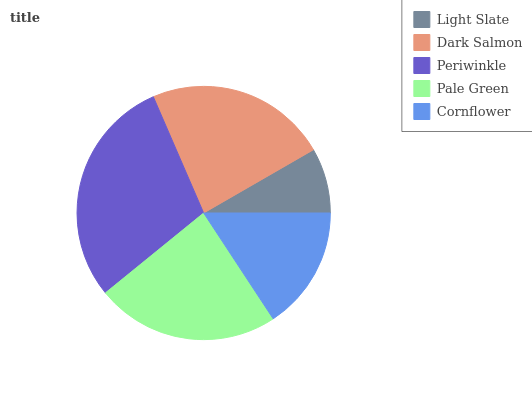Is Light Slate the minimum?
Answer yes or no. Yes. Is Periwinkle the maximum?
Answer yes or no. Yes. Is Dark Salmon the minimum?
Answer yes or no. No. Is Dark Salmon the maximum?
Answer yes or no. No. Is Dark Salmon greater than Light Slate?
Answer yes or no. Yes. Is Light Slate less than Dark Salmon?
Answer yes or no. Yes. Is Light Slate greater than Dark Salmon?
Answer yes or no. No. Is Dark Salmon less than Light Slate?
Answer yes or no. No. Is Dark Salmon the high median?
Answer yes or no. Yes. Is Dark Salmon the low median?
Answer yes or no. Yes. Is Pale Green the high median?
Answer yes or no. No. Is Periwinkle the low median?
Answer yes or no. No. 